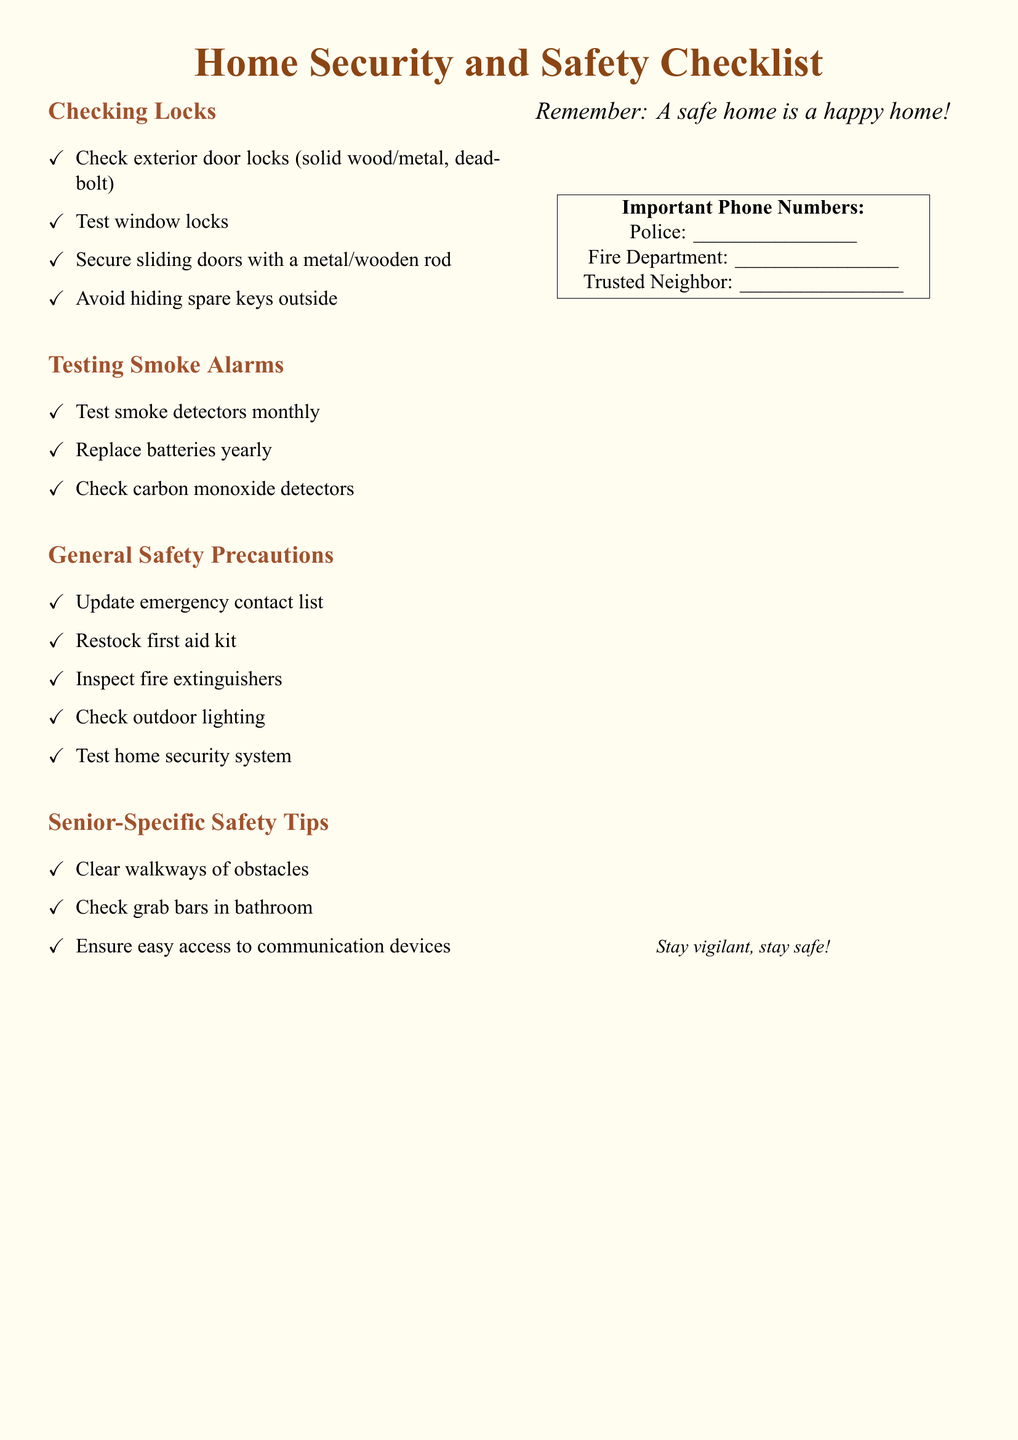What should be checked for exterior door locks? The list specifies checking solid wood/metal doors and deadbolts for exterior door locks.
Answer: solid wood/metal, deadbolt How often should smoke detectors be tested? The document states that smoke detectors should be tested monthly.
Answer: monthly What is one way to secure sliding doors? The checklist suggests securing sliding doors with a metal or wooden rod.
Answer: metal/wooden rod How frequently should batteries in smoke alarms be replaced? It is mentioned that batteries should be replaced yearly.
Answer: yearly What is one of the senior-specific safety tips? One senior-specific tip includes clearing walkways of obstacles.
Answer: clear walkways of obstacles What is recommended to update for emergency preparedness? The document recommends updating the emergency contact list.
Answer: emergency contact list What should be checked alongside fire extinguishers? The document mentions inspecting fire extinguishers, which should be checked.
Answer: fire extinguishers What is the essential message highlighted at the end of the document? The document emphasizes that a safe home leads to happiness.
Answer: A safe home is a happy home 